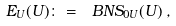<formula> <loc_0><loc_0><loc_500><loc_500>E _ { U } ( U ) \colon = { \ B N S } _ { 0 U } ( U ) \, ,</formula> 